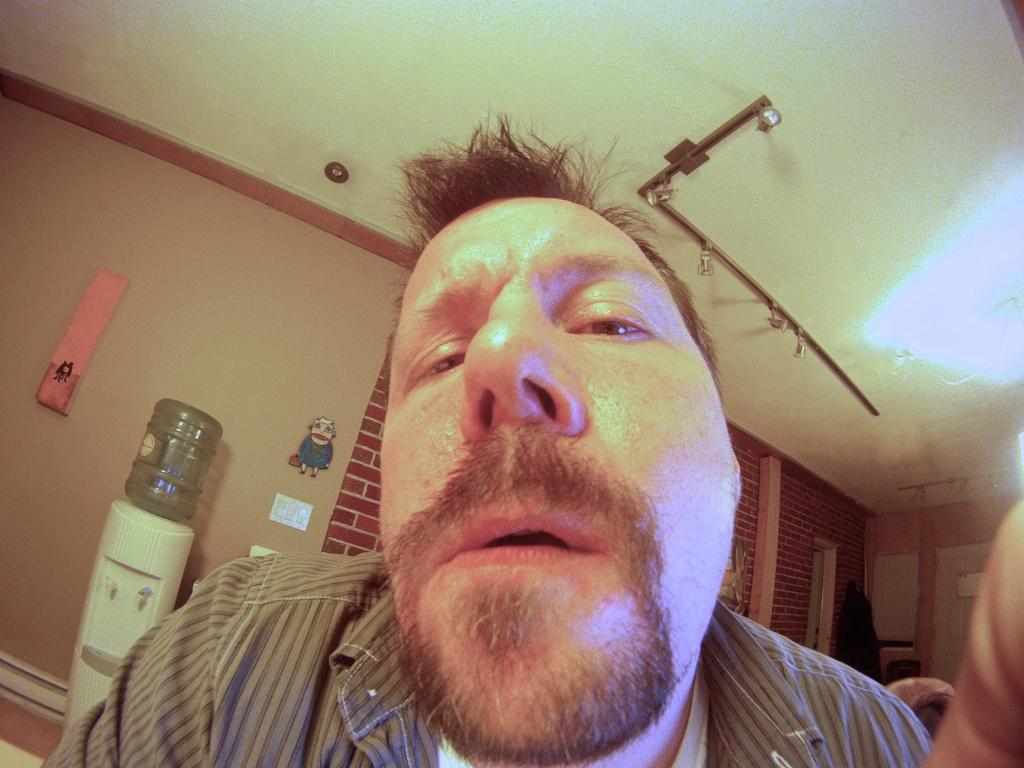Who is present in the image? There is a man in the image. What is the man doing in the image? The facts provided do not specify what the man is doing. What can be seen on the water purifier? There is a water can on the water purifier. What is on the wall in the image? There are boards on the wall. What can be seen in terms of lighting in the image? There are lights in the image. What other objects are present in the image? The facts provided do not specify any other objects. What type of songs can be heard in the background of the image? There is no information about any songs or audio in the image, so it cannot be determined what type of songs might be heard. 